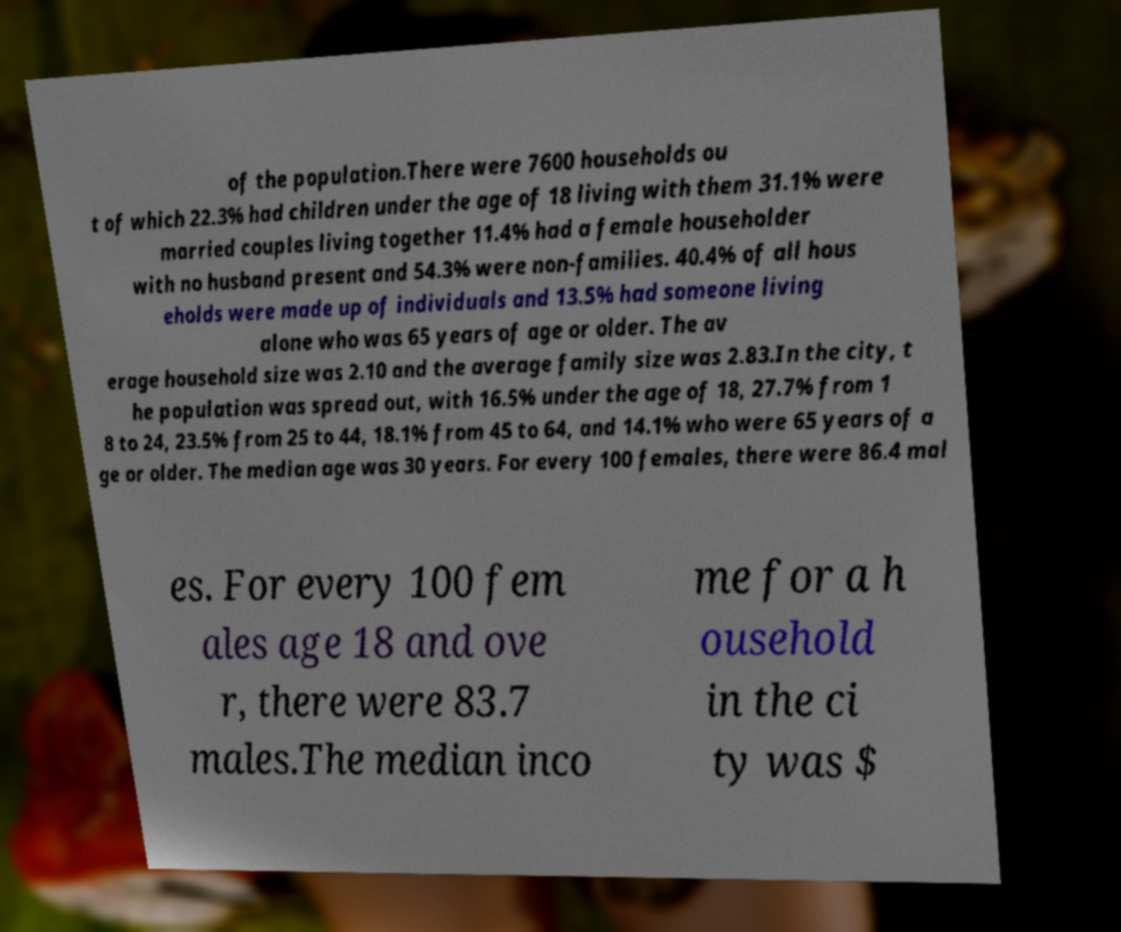What messages or text are displayed in this image? I need them in a readable, typed format. of the population.There were 7600 households ou t of which 22.3% had children under the age of 18 living with them 31.1% were married couples living together 11.4% had a female householder with no husband present and 54.3% were non-families. 40.4% of all hous eholds were made up of individuals and 13.5% had someone living alone who was 65 years of age or older. The av erage household size was 2.10 and the average family size was 2.83.In the city, t he population was spread out, with 16.5% under the age of 18, 27.7% from 1 8 to 24, 23.5% from 25 to 44, 18.1% from 45 to 64, and 14.1% who were 65 years of a ge or older. The median age was 30 years. For every 100 females, there were 86.4 mal es. For every 100 fem ales age 18 and ove r, there were 83.7 males.The median inco me for a h ousehold in the ci ty was $ 